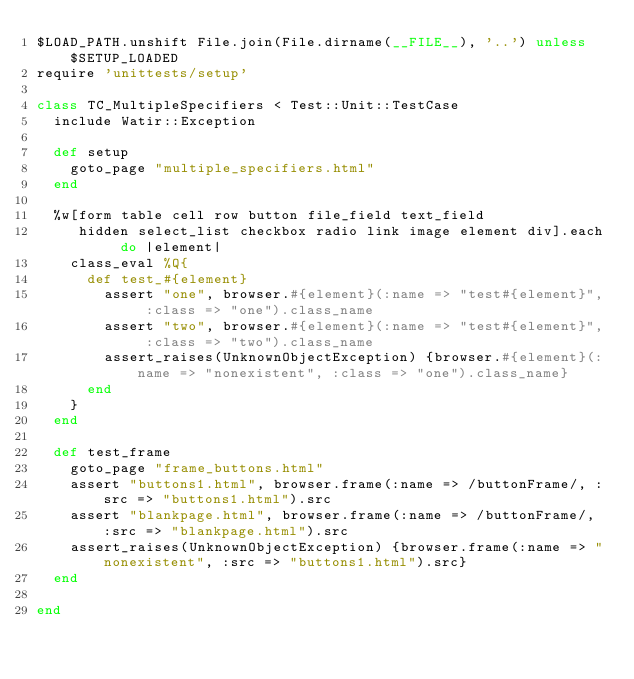<code> <loc_0><loc_0><loc_500><loc_500><_Ruby_>$LOAD_PATH.unshift File.join(File.dirname(__FILE__), '..') unless $SETUP_LOADED
require 'unittests/setup'

class TC_MultipleSpecifiers < Test::Unit::TestCase
  include Watir::Exception
  
  def setup
    goto_page "multiple_specifiers.html"
  end

  %w[form table cell row button file_field text_field
     hidden select_list checkbox radio link image element div].each do |element|
    class_eval %Q{
      def test_#{element} 
        assert "one", browser.#{element}(:name => "test#{element}", :class => "one").class_name
        assert "two", browser.#{element}(:name => "test#{element}", :class => "two").class_name
        assert_raises(UnknownObjectException) {browser.#{element}(:name => "nonexistent", :class => "one").class_name}      
      end
    }
  end

  def test_frame
    goto_page "frame_buttons.html"
    assert "buttons1.html", browser.frame(:name => /buttonFrame/, :src => "buttons1.html").src
    assert "blankpage.html", browser.frame(:name => /buttonFrame/, :src => "blankpage.html").src
    assert_raises(UnknownObjectException) {browser.frame(:name => "nonexistent", :src => "buttons1.html").src}      
  end

end
</code> 